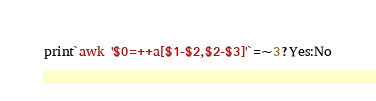<code> <loc_0><loc_0><loc_500><loc_500><_Perl_>print`awk '$0=++a[$1-$2,$2-$3]'`=~3?Yes:No</code> 